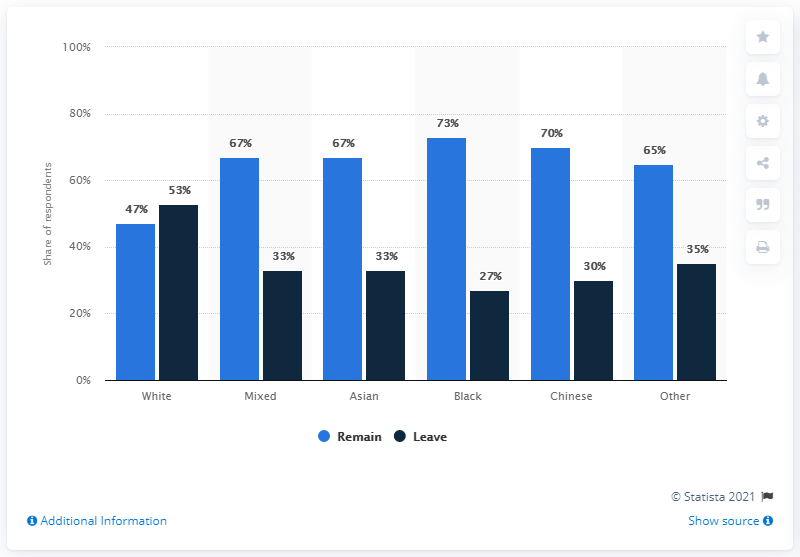Specify some key components in this picture. The highest value of the blue bar is 73. 